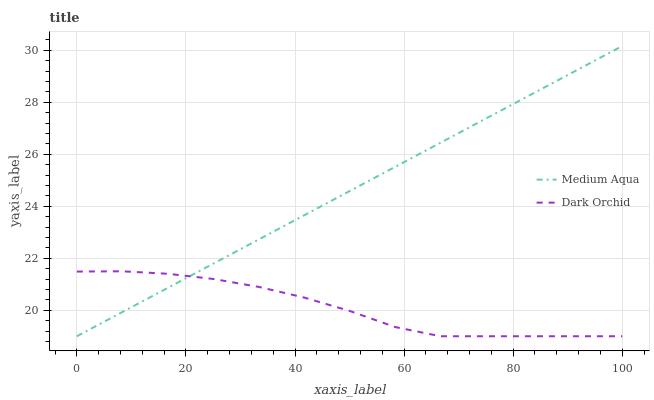Does Dark Orchid have the maximum area under the curve?
Answer yes or no. No. Is Dark Orchid the smoothest?
Answer yes or no. No. Does Dark Orchid have the highest value?
Answer yes or no. No. 